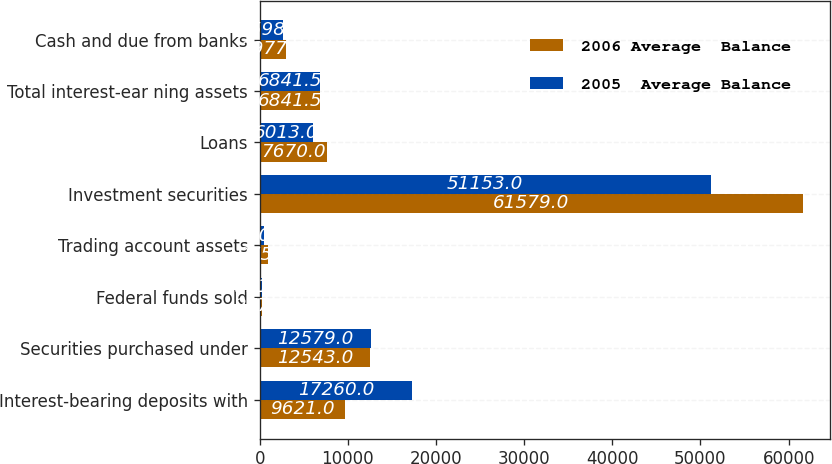Convert chart to OTSL. <chart><loc_0><loc_0><loc_500><loc_500><stacked_bar_chart><ecel><fcel>Interest-bearing deposits with<fcel>Securities purchased under<fcel>Federal funds sold<fcel>Trading account assets<fcel>Investment securities<fcel>Loans<fcel>Total interest-ear ning assets<fcel>Cash and due from banks<nl><fcel>2006 Average  Balance<fcel>9621<fcel>12543<fcel>277<fcel>975<fcel>61579<fcel>7670<fcel>6841.5<fcel>2977<nl><fcel>2005  Average Balance<fcel>17260<fcel>12579<fcel>311<fcel>470<fcel>51153<fcel>6013<fcel>6841.5<fcel>2598<nl></chart> 